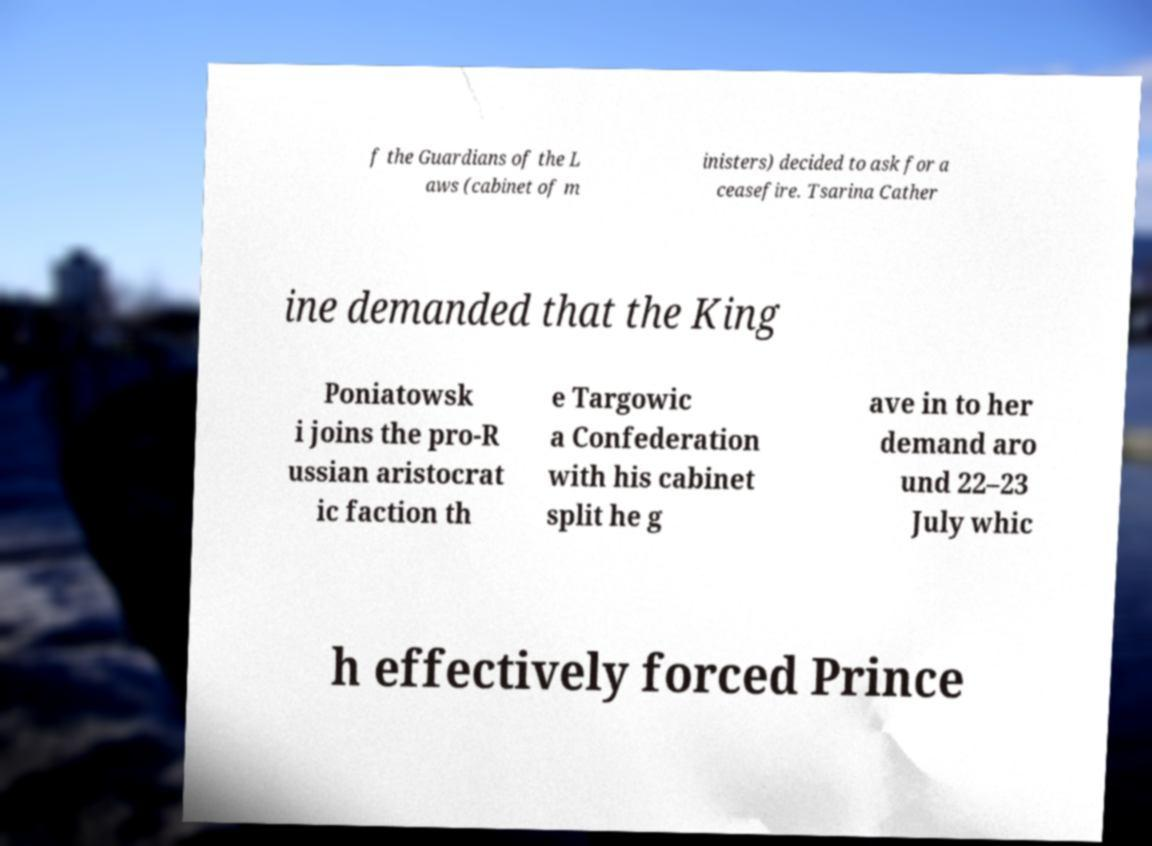Please read and relay the text visible in this image. What does it say? f the Guardians of the L aws (cabinet of m inisters) decided to ask for a ceasefire. Tsarina Cather ine demanded that the King Poniatowsk i joins the pro-R ussian aristocrat ic faction th e Targowic a Confederation with his cabinet split he g ave in to her demand aro und 22–23 July whic h effectively forced Prince 